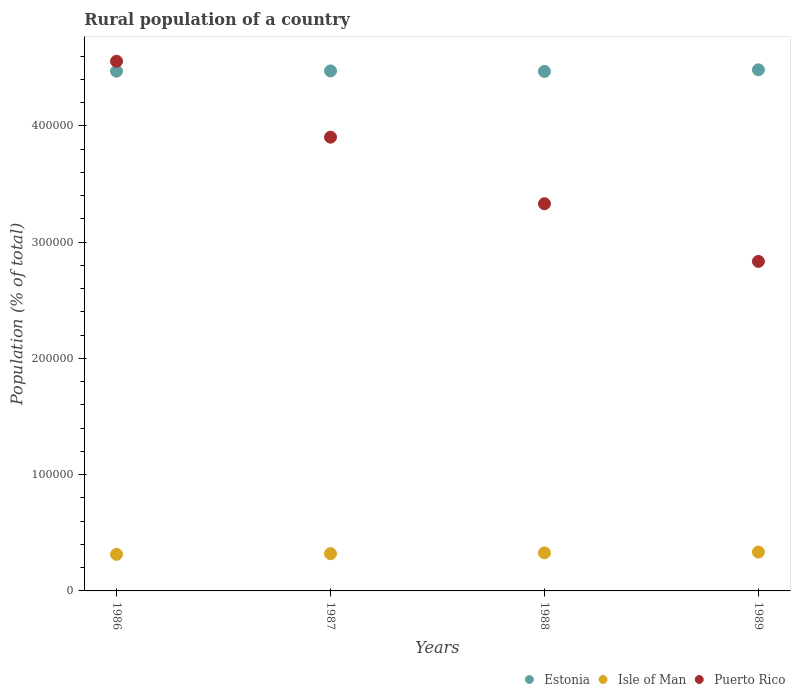How many different coloured dotlines are there?
Offer a terse response. 3. What is the rural population in Isle of Man in 1986?
Provide a succinct answer. 3.15e+04. Across all years, what is the maximum rural population in Puerto Rico?
Provide a succinct answer. 4.56e+05. Across all years, what is the minimum rural population in Estonia?
Ensure brevity in your answer.  4.47e+05. What is the total rural population in Isle of Man in the graph?
Give a very brief answer. 1.30e+05. What is the difference between the rural population in Isle of Man in 1987 and that in 1988?
Provide a short and direct response. -703. What is the difference between the rural population in Estonia in 1989 and the rural population in Puerto Rico in 1986?
Your answer should be compact. -7369. What is the average rural population in Isle of Man per year?
Offer a terse response. 3.24e+04. In the year 1988, what is the difference between the rural population in Isle of Man and rural population in Estonia?
Provide a succinct answer. -4.14e+05. What is the ratio of the rural population in Puerto Rico in 1986 to that in 1989?
Provide a short and direct response. 1.61. Is the rural population in Estonia in 1986 less than that in 1989?
Provide a short and direct response. Yes. What is the difference between the highest and the second highest rural population in Puerto Rico?
Give a very brief answer. 6.53e+04. What is the difference between the highest and the lowest rural population in Estonia?
Your answer should be compact. 1390. Is the rural population in Estonia strictly greater than the rural population in Puerto Rico over the years?
Provide a succinct answer. No. Is the rural population in Puerto Rico strictly less than the rural population in Estonia over the years?
Offer a terse response. No. How many dotlines are there?
Keep it short and to the point. 3. Are the values on the major ticks of Y-axis written in scientific E-notation?
Offer a terse response. No. Does the graph contain any zero values?
Ensure brevity in your answer.  No. Does the graph contain grids?
Provide a succinct answer. No. How many legend labels are there?
Ensure brevity in your answer.  3. What is the title of the graph?
Your response must be concise. Rural population of a country. Does "East Asia (developing only)" appear as one of the legend labels in the graph?
Your answer should be very brief. No. What is the label or title of the Y-axis?
Keep it short and to the point. Population (% of total). What is the Population (% of total) in Estonia in 1986?
Your response must be concise. 4.47e+05. What is the Population (% of total) of Isle of Man in 1986?
Make the answer very short. 3.15e+04. What is the Population (% of total) of Puerto Rico in 1986?
Offer a very short reply. 4.56e+05. What is the Population (% of total) in Estonia in 1987?
Provide a short and direct response. 4.47e+05. What is the Population (% of total) in Isle of Man in 1987?
Offer a terse response. 3.21e+04. What is the Population (% of total) of Puerto Rico in 1987?
Offer a very short reply. 3.90e+05. What is the Population (% of total) of Estonia in 1988?
Keep it short and to the point. 4.47e+05. What is the Population (% of total) in Isle of Man in 1988?
Make the answer very short. 3.28e+04. What is the Population (% of total) in Puerto Rico in 1988?
Give a very brief answer. 3.33e+05. What is the Population (% of total) in Estonia in 1989?
Provide a short and direct response. 4.48e+05. What is the Population (% of total) in Isle of Man in 1989?
Offer a terse response. 3.34e+04. What is the Population (% of total) in Puerto Rico in 1989?
Provide a short and direct response. 2.83e+05. Across all years, what is the maximum Population (% of total) of Estonia?
Offer a terse response. 4.48e+05. Across all years, what is the maximum Population (% of total) in Isle of Man?
Offer a terse response. 3.34e+04. Across all years, what is the maximum Population (% of total) of Puerto Rico?
Ensure brevity in your answer.  4.56e+05. Across all years, what is the minimum Population (% of total) in Estonia?
Keep it short and to the point. 4.47e+05. Across all years, what is the minimum Population (% of total) of Isle of Man?
Your answer should be compact. 3.15e+04. Across all years, what is the minimum Population (% of total) in Puerto Rico?
Ensure brevity in your answer.  2.83e+05. What is the total Population (% of total) of Estonia in the graph?
Provide a short and direct response. 1.79e+06. What is the total Population (% of total) in Isle of Man in the graph?
Give a very brief answer. 1.30e+05. What is the total Population (% of total) in Puerto Rico in the graph?
Your response must be concise. 1.46e+06. What is the difference between the Population (% of total) in Estonia in 1986 and that in 1987?
Offer a terse response. -264. What is the difference between the Population (% of total) in Isle of Man in 1986 and that in 1987?
Your response must be concise. -593. What is the difference between the Population (% of total) in Puerto Rico in 1986 and that in 1987?
Keep it short and to the point. 6.53e+04. What is the difference between the Population (% of total) in Estonia in 1986 and that in 1988?
Keep it short and to the point. 180. What is the difference between the Population (% of total) in Isle of Man in 1986 and that in 1988?
Provide a succinct answer. -1296. What is the difference between the Population (% of total) in Puerto Rico in 1986 and that in 1988?
Make the answer very short. 1.23e+05. What is the difference between the Population (% of total) of Estonia in 1986 and that in 1989?
Provide a succinct answer. -1210. What is the difference between the Population (% of total) of Isle of Man in 1986 and that in 1989?
Ensure brevity in your answer.  -1956. What is the difference between the Population (% of total) in Puerto Rico in 1986 and that in 1989?
Your answer should be very brief. 1.72e+05. What is the difference between the Population (% of total) in Estonia in 1987 and that in 1988?
Offer a terse response. 444. What is the difference between the Population (% of total) of Isle of Man in 1987 and that in 1988?
Make the answer very short. -703. What is the difference between the Population (% of total) in Puerto Rico in 1987 and that in 1988?
Ensure brevity in your answer.  5.73e+04. What is the difference between the Population (% of total) of Estonia in 1987 and that in 1989?
Your answer should be compact. -946. What is the difference between the Population (% of total) in Isle of Man in 1987 and that in 1989?
Your answer should be very brief. -1363. What is the difference between the Population (% of total) of Puerto Rico in 1987 and that in 1989?
Ensure brevity in your answer.  1.07e+05. What is the difference between the Population (% of total) of Estonia in 1988 and that in 1989?
Ensure brevity in your answer.  -1390. What is the difference between the Population (% of total) in Isle of Man in 1988 and that in 1989?
Provide a succinct answer. -660. What is the difference between the Population (% of total) in Puerto Rico in 1988 and that in 1989?
Ensure brevity in your answer.  4.96e+04. What is the difference between the Population (% of total) in Estonia in 1986 and the Population (% of total) in Isle of Man in 1987?
Your answer should be compact. 4.15e+05. What is the difference between the Population (% of total) of Estonia in 1986 and the Population (% of total) of Puerto Rico in 1987?
Your response must be concise. 5.67e+04. What is the difference between the Population (% of total) of Isle of Man in 1986 and the Population (% of total) of Puerto Rico in 1987?
Provide a succinct answer. -3.59e+05. What is the difference between the Population (% of total) of Estonia in 1986 and the Population (% of total) of Isle of Man in 1988?
Provide a short and direct response. 4.14e+05. What is the difference between the Population (% of total) in Estonia in 1986 and the Population (% of total) in Puerto Rico in 1988?
Ensure brevity in your answer.  1.14e+05. What is the difference between the Population (% of total) of Isle of Man in 1986 and the Population (% of total) of Puerto Rico in 1988?
Your answer should be compact. -3.02e+05. What is the difference between the Population (% of total) of Estonia in 1986 and the Population (% of total) of Isle of Man in 1989?
Your response must be concise. 4.14e+05. What is the difference between the Population (% of total) of Estonia in 1986 and the Population (% of total) of Puerto Rico in 1989?
Provide a short and direct response. 1.64e+05. What is the difference between the Population (% of total) in Isle of Man in 1986 and the Population (% of total) in Puerto Rico in 1989?
Your answer should be very brief. -2.52e+05. What is the difference between the Population (% of total) of Estonia in 1987 and the Population (% of total) of Isle of Man in 1988?
Keep it short and to the point. 4.15e+05. What is the difference between the Population (% of total) in Estonia in 1987 and the Population (% of total) in Puerto Rico in 1988?
Offer a terse response. 1.14e+05. What is the difference between the Population (% of total) in Isle of Man in 1987 and the Population (% of total) in Puerto Rico in 1988?
Ensure brevity in your answer.  -3.01e+05. What is the difference between the Population (% of total) in Estonia in 1987 and the Population (% of total) in Isle of Man in 1989?
Your response must be concise. 4.14e+05. What is the difference between the Population (% of total) of Estonia in 1987 and the Population (% of total) of Puerto Rico in 1989?
Offer a terse response. 1.64e+05. What is the difference between the Population (% of total) in Isle of Man in 1987 and the Population (% of total) in Puerto Rico in 1989?
Keep it short and to the point. -2.51e+05. What is the difference between the Population (% of total) in Estonia in 1988 and the Population (% of total) in Isle of Man in 1989?
Your answer should be very brief. 4.13e+05. What is the difference between the Population (% of total) of Estonia in 1988 and the Population (% of total) of Puerto Rico in 1989?
Provide a succinct answer. 1.63e+05. What is the difference between the Population (% of total) of Isle of Man in 1988 and the Population (% of total) of Puerto Rico in 1989?
Offer a terse response. -2.51e+05. What is the average Population (% of total) of Estonia per year?
Your answer should be very brief. 4.47e+05. What is the average Population (% of total) of Isle of Man per year?
Your answer should be compact. 3.24e+04. What is the average Population (% of total) in Puerto Rico per year?
Give a very brief answer. 3.66e+05. In the year 1986, what is the difference between the Population (% of total) in Estonia and Population (% of total) in Isle of Man?
Your answer should be very brief. 4.16e+05. In the year 1986, what is the difference between the Population (% of total) of Estonia and Population (% of total) of Puerto Rico?
Offer a very short reply. -8579. In the year 1986, what is the difference between the Population (% of total) in Isle of Man and Population (% of total) in Puerto Rico?
Offer a very short reply. -4.24e+05. In the year 1987, what is the difference between the Population (% of total) of Estonia and Population (% of total) of Isle of Man?
Provide a succinct answer. 4.15e+05. In the year 1987, what is the difference between the Population (% of total) in Estonia and Population (% of total) in Puerto Rico?
Your answer should be compact. 5.70e+04. In the year 1987, what is the difference between the Population (% of total) of Isle of Man and Population (% of total) of Puerto Rico?
Provide a succinct answer. -3.58e+05. In the year 1988, what is the difference between the Population (% of total) in Estonia and Population (% of total) in Isle of Man?
Offer a very short reply. 4.14e+05. In the year 1988, what is the difference between the Population (% of total) of Estonia and Population (% of total) of Puerto Rico?
Your answer should be very brief. 1.14e+05. In the year 1988, what is the difference between the Population (% of total) in Isle of Man and Population (% of total) in Puerto Rico?
Make the answer very short. -3.00e+05. In the year 1989, what is the difference between the Population (% of total) of Estonia and Population (% of total) of Isle of Man?
Your answer should be compact. 4.15e+05. In the year 1989, what is the difference between the Population (% of total) in Estonia and Population (% of total) in Puerto Rico?
Offer a terse response. 1.65e+05. In the year 1989, what is the difference between the Population (% of total) in Isle of Man and Population (% of total) in Puerto Rico?
Your answer should be compact. -2.50e+05. What is the ratio of the Population (% of total) in Estonia in 1986 to that in 1987?
Give a very brief answer. 1. What is the ratio of the Population (% of total) of Isle of Man in 1986 to that in 1987?
Provide a succinct answer. 0.98. What is the ratio of the Population (% of total) in Puerto Rico in 1986 to that in 1987?
Make the answer very short. 1.17. What is the ratio of the Population (% of total) of Isle of Man in 1986 to that in 1988?
Your response must be concise. 0.96. What is the ratio of the Population (% of total) in Puerto Rico in 1986 to that in 1988?
Make the answer very short. 1.37. What is the ratio of the Population (% of total) in Isle of Man in 1986 to that in 1989?
Provide a short and direct response. 0.94. What is the ratio of the Population (% of total) of Puerto Rico in 1986 to that in 1989?
Provide a short and direct response. 1.61. What is the ratio of the Population (% of total) in Isle of Man in 1987 to that in 1988?
Give a very brief answer. 0.98. What is the ratio of the Population (% of total) in Puerto Rico in 1987 to that in 1988?
Keep it short and to the point. 1.17. What is the ratio of the Population (% of total) of Estonia in 1987 to that in 1989?
Offer a very short reply. 1. What is the ratio of the Population (% of total) of Isle of Man in 1987 to that in 1989?
Your answer should be very brief. 0.96. What is the ratio of the Population (% of total) in Puerto Rico in 1987 to that in 1989?
Give a very brief answer. 1.38. What is the ratio of the Population (% of total) of Estonia in 1988 to that in 1989?
Provide a short and direct response. 1. What is the ratio of the Population (% of total) of Isle of Man in 1988 to that in 1989?
Keep it short and to the point. 0.98. What is the ratio of the Population (% of total) of Puerto Rico in 1988 to that in 1989?
Your answer should be very brief. 1.18. What is the difference between the highest and the second highest Population (% of total) of Estonia?
Make the answer very short. 946. What is the difference between the highest and the second highest Population (% of total) of Isle of Man?
Offer a very short reply. 660. What is the difference between the highest and the second highest Population (% of total) of Puerto Rico?
Provide a succinct answer. 6.53e+04. What is the difference between the highest and the lowest Population (% of total) in Estonia?
Provide a short and direct response. 1390. What is the difference between the highest and the lowest Population (% of total) of Isle of Man?
Your answer should be very brief. 1956. What is the difference between the highest and the lowest Population (% of total) in Puerto Rico?
Provide a succinct answer. 1.72e+05. 